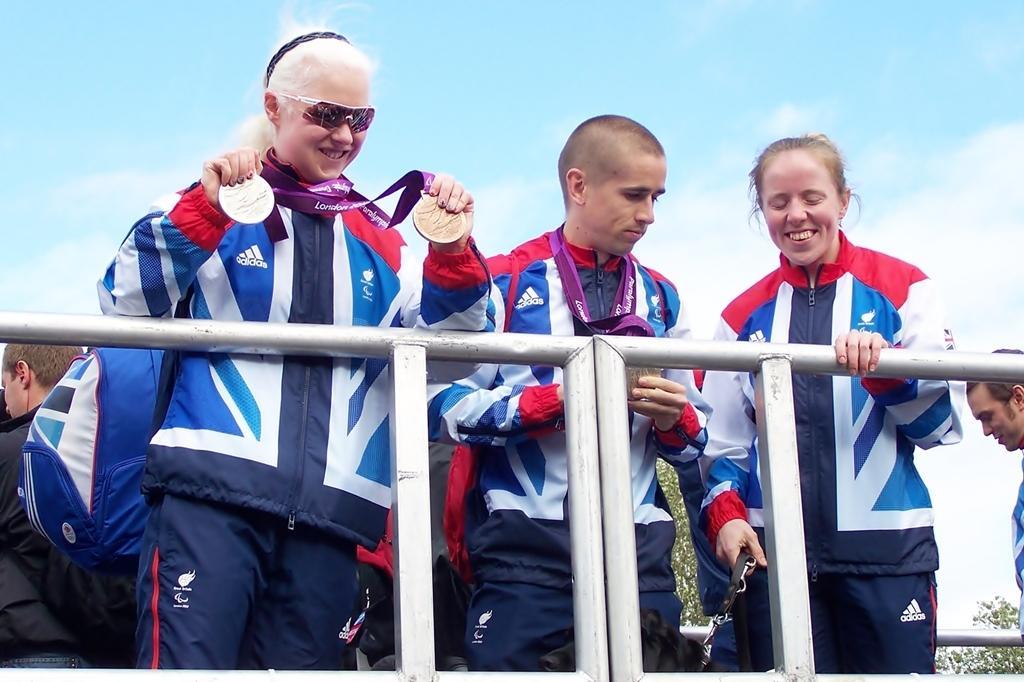In one or two sentences, can you explain what this image depicts? In this picture we can see some people standing here, these two persons wore medals, in the background there is a tree, we can see the sky at the top of the picture. 